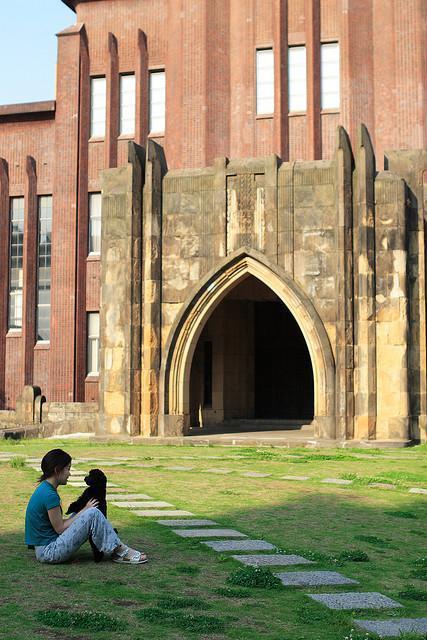How many people are visible?
Give a very brief answer. 1. 